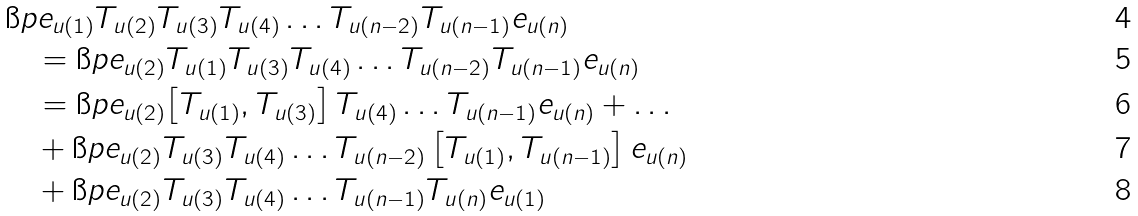Convert formula to latex. <formula><loc_0><loc_0><loc_500><loc_500>& \i p { e _ { u ( 1 ) } } { T _ { u ( 2 ) } T _ { u ( 3 ) } T _ { u ( 4 ) } \dots T _ { u ( n - 2 ) } T _ { u ( n - 1 ) } e _ { u ( n ) } } \\ & \quad = \i p { e _ { u ( 2 ) } } { T _ { u ( 1 ) } T _ { u ( 3 ) } T _ { u ( 4 ) } \dots T _ { u ( n - 2 ) } T _ { u ( n - 1 ) } e _ { u ( n ) } } \\ & \quad = \i p { e _ { u ( 2 ) } } { \left [ T _ { u ( 1 ) } , T _ { u ( 3 ) } \right ] T _ { u ( 4 ) } \dots T _ { u ( n - 1 ) } e _ { u ( n ) } } + \dots \\ & \quad + \i p { e _ { u ( 2 ) } } { T _ { u ( 3 ) } T _ { u ( 4 ) } \dots T _ { u ( n - 2 ) } \left [ T _ { u ( 1 ) } , T _ { u ( n - 1 ) } \right ] e _ { u ( n ) } } \\ & \quad + \i p { e _ { u ( 2 ) } } { T _ { u ( 3 ) } T _ { u ( 4 ) } \dots T _ { u ( n - 1 ) } T _ { u ( n ) } e _ { u ( 1 ) } }</formula> 